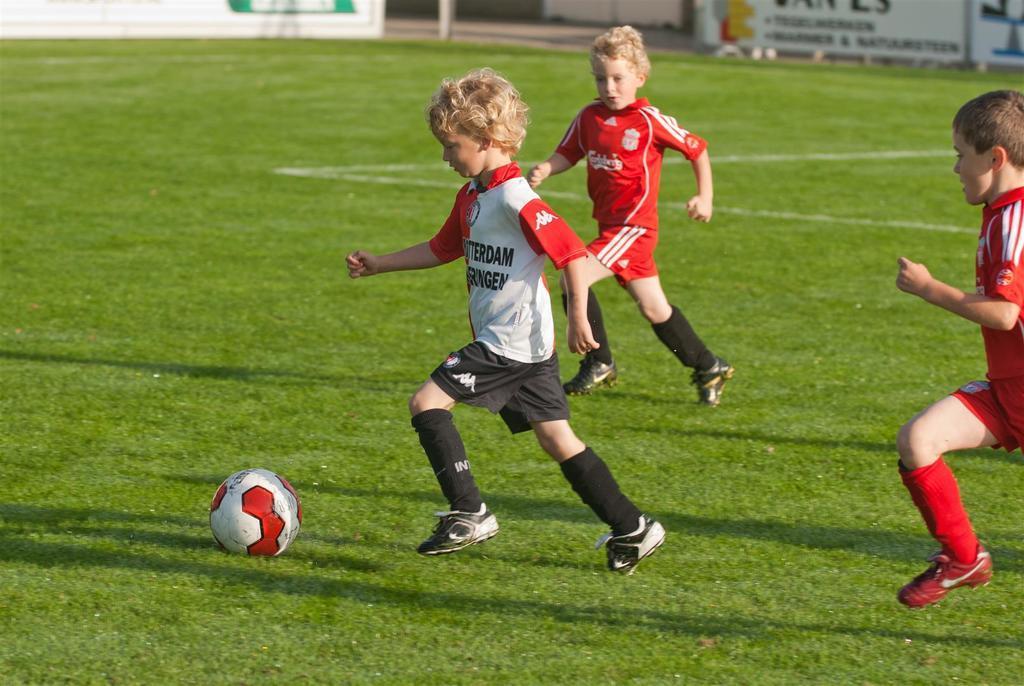In one or two sentences, can you explain what this image depicts? In this image we can see three children running on the ground. In the background we can see advertisement and ball. 